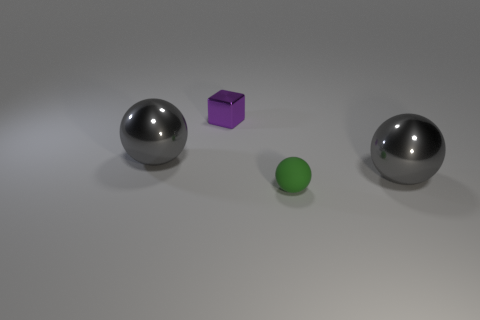Subtract all shiny balls. How many balls are left? 1 Subtract all green balls. How many balls are left? 2 Subtract 2 balls. How many balls are left? 1 Subtract all red cylinders. How many gray balls are left? 2 Add 1 large gray cylinders. How many objects exist? 5 Subtract all blocks. How many objects are left? 3 Subtract all purple metal cubes. Subtract all gray balls. How many objects are left? 1 Add 3 large balls. How many large balls are left? 5 Add 2 tiny brown cylinders. How many tiny brown cylinders exist? 2 Subtract 0 red balls. How many objects are left? 4 